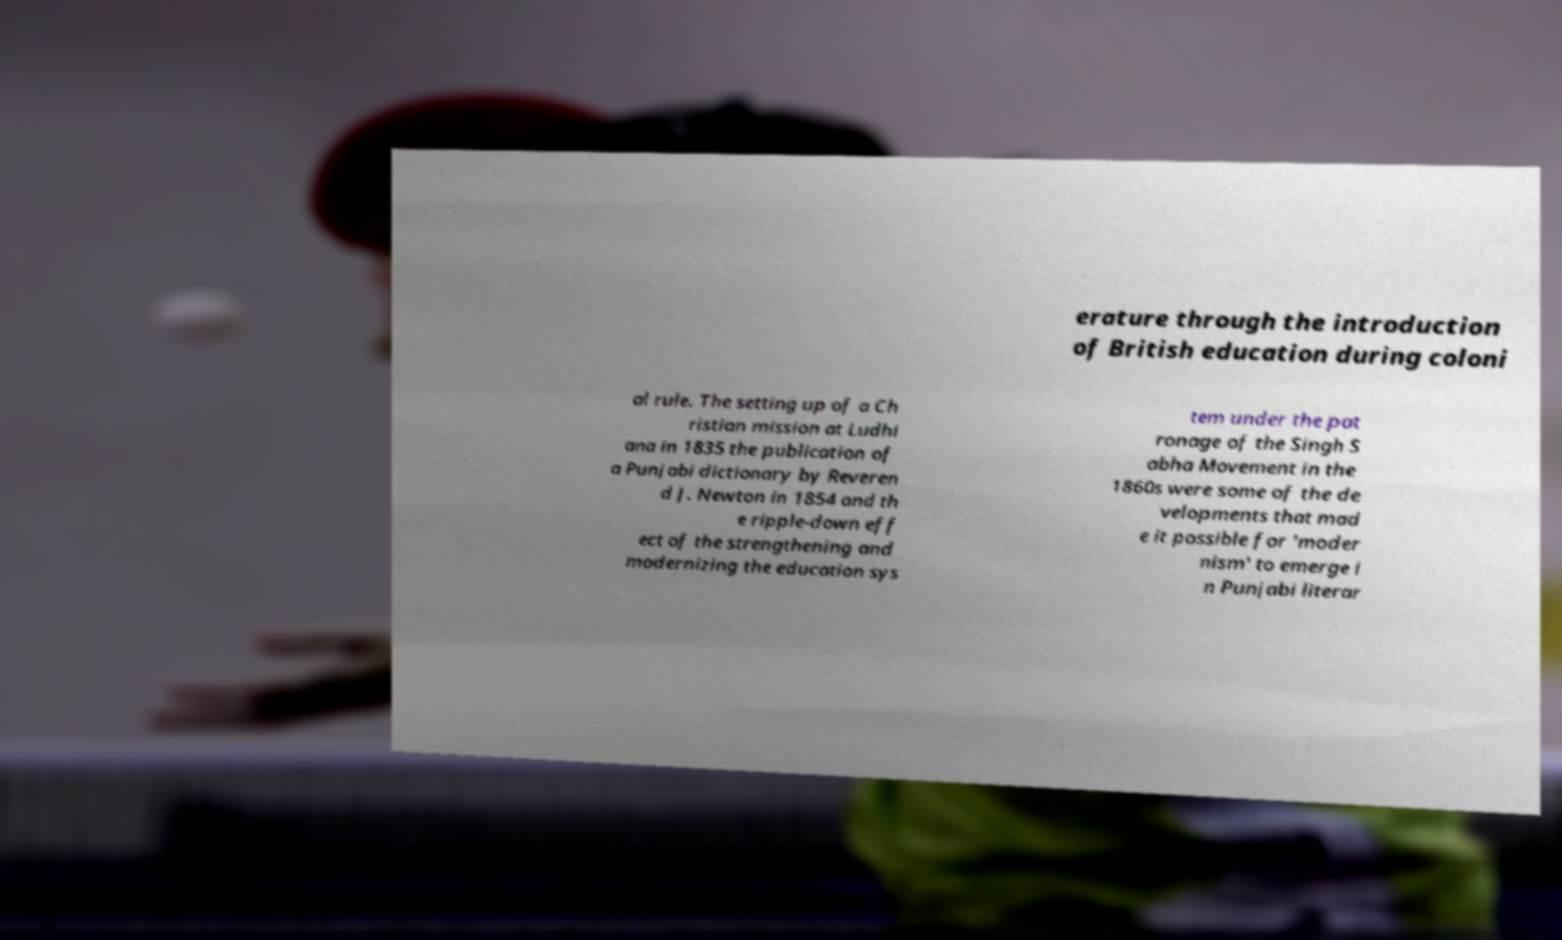Can you read and provide the text displayed in the image?This photo seems to have some interesting text. Can you extract and type it out for me? erature through the introduction of British education during coloni al rule. The setting up of a Ch ristian mission at Ludhi ana in 1835 the publication of a Punjabi dictionary by Reveren d J. Newton in 1854 and th e ripple-down eff ect of the strengthening and modernizing the education sys tem under the pat ronage of the Singh S abha Movement in the 1860s were some of the de velopments that mad e it possible for 'moder nism' to emerge i n Punjabi literar 